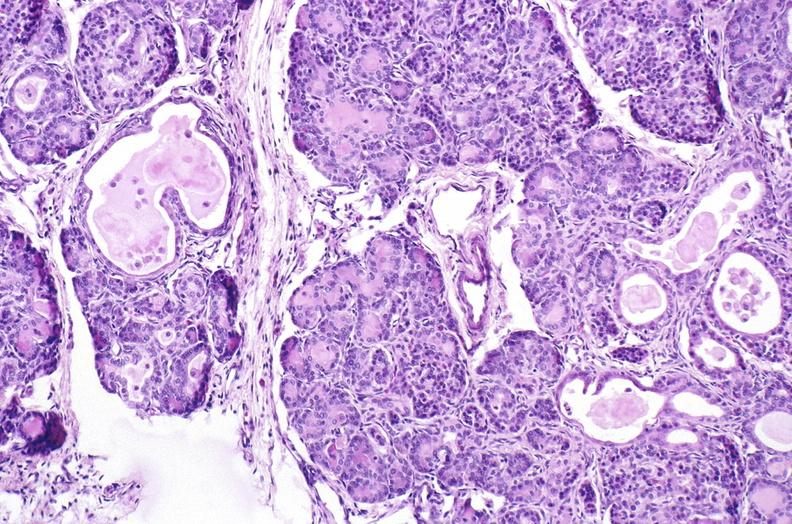s pancreas present?
Answer the question using a single word or phrase. Yes 